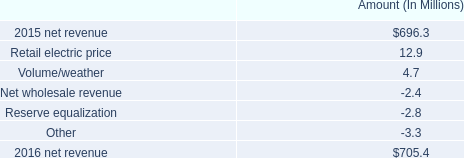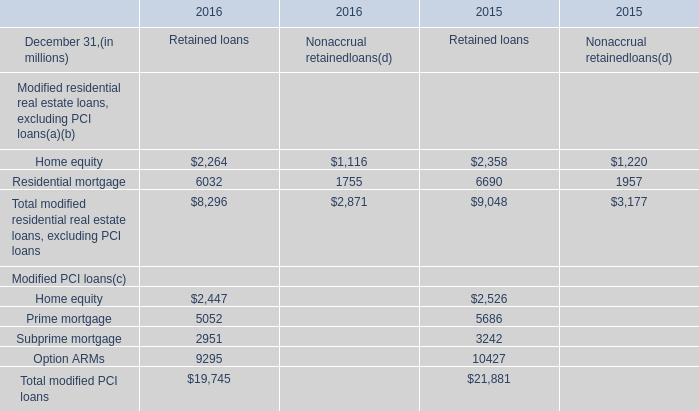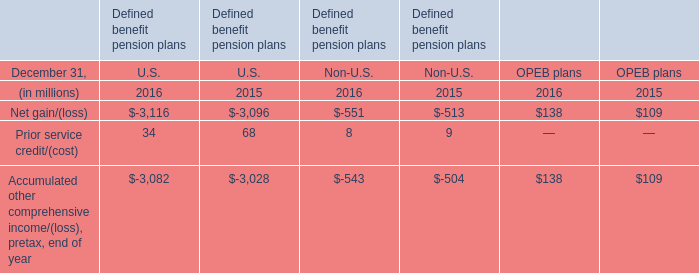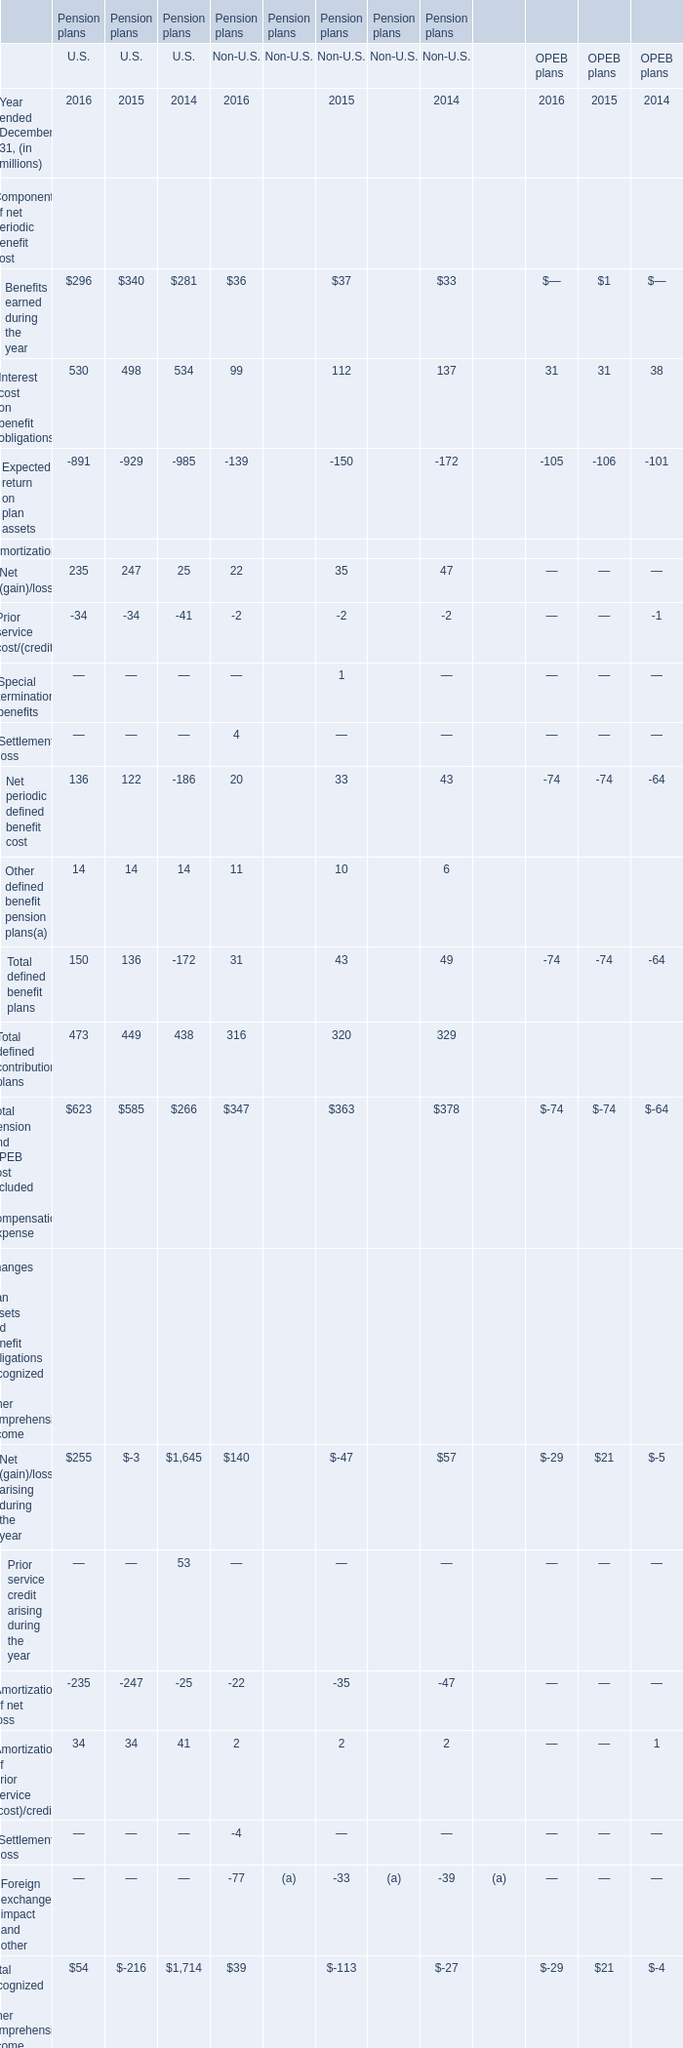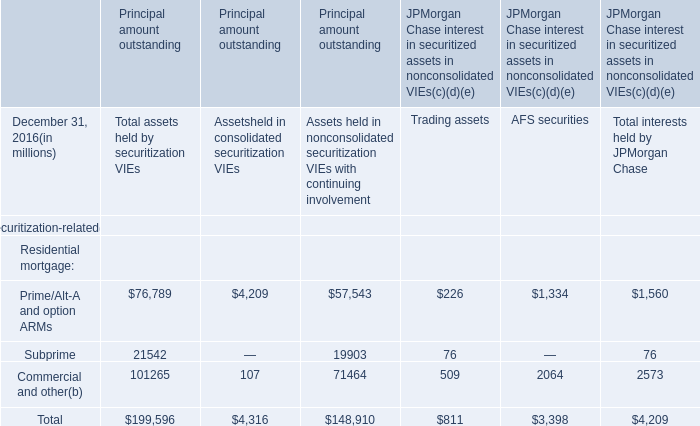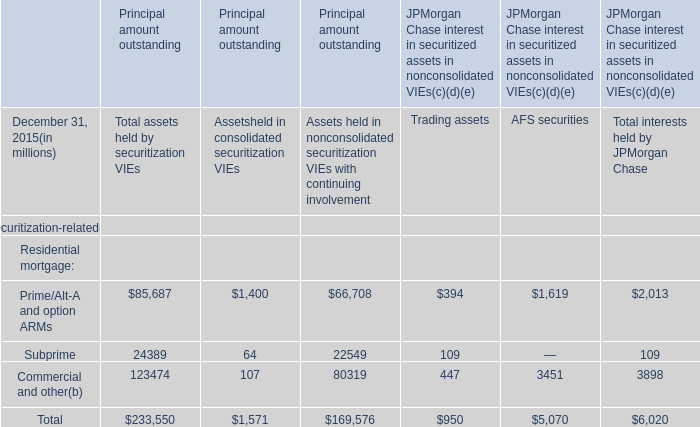What's the growing rate of Interest cost on benefit obligations for OPEB plans in 2015 ended December 31? 
Computations: ((31 - 38) / 38)
Answer: -0.18421. 